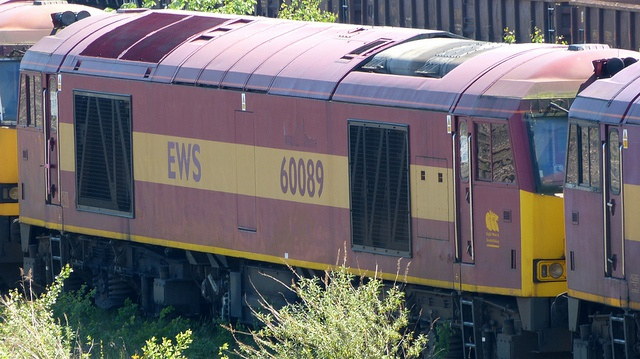Describe the objects in this image and their specific colors. I can see a train in gray, white, black, lavender, and tan tones in this image. 